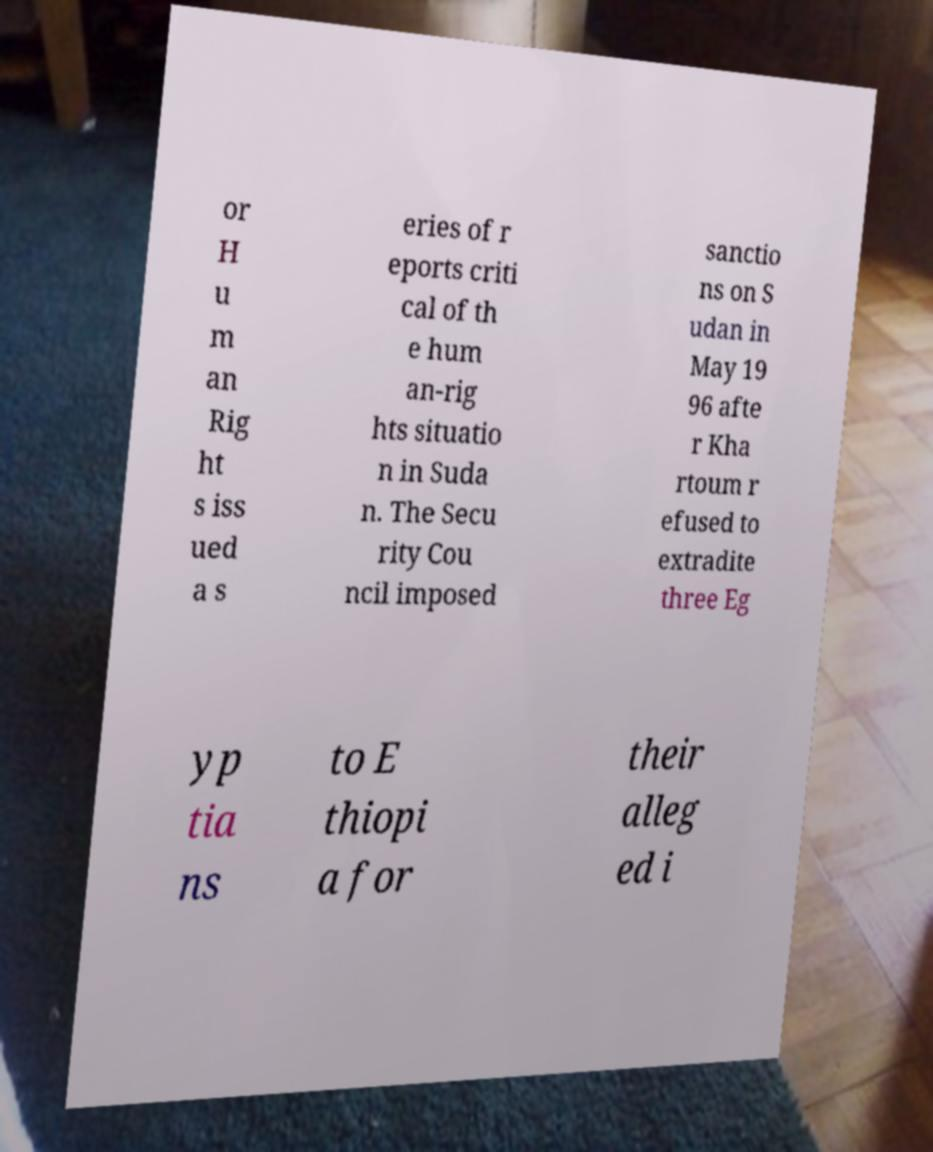There's text embedded in this image that I need extracted. Can you transcribe it verbatim? or H u m an Rig ht s iss ued a s eries of r eports criti cal of th e hum an-rig hts situatio n in Suda n. The Secu rity Cou ncil imposed sanctio ns on S udan in May 19 96 afte r Kha rtoum r efused to extradite three Eg yp tia ns to E thiopi a for their alleg ed i 